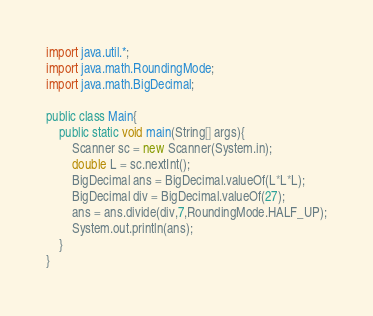Convert code to text. <code><loc_0><loc_0><loc_500><loc_500><_Java_>import java.util.*;
import java.math.RoundingMode;
import java.math.BigDecimal;
 
public class Main{
	public static void main(String[] args){
		Scanner sc = new Scanner(System.in);
		double L = sc.nextInt();
		BigDecimal ans = BigDecimal.valueOf(L*L*L);
		BigDecimal div = BigDecimal.valueOf(27);
		ans = ans.divide(div,7,RoundingMode.HALF_UP);
		System.out.println(ans);
	}
}</code> 